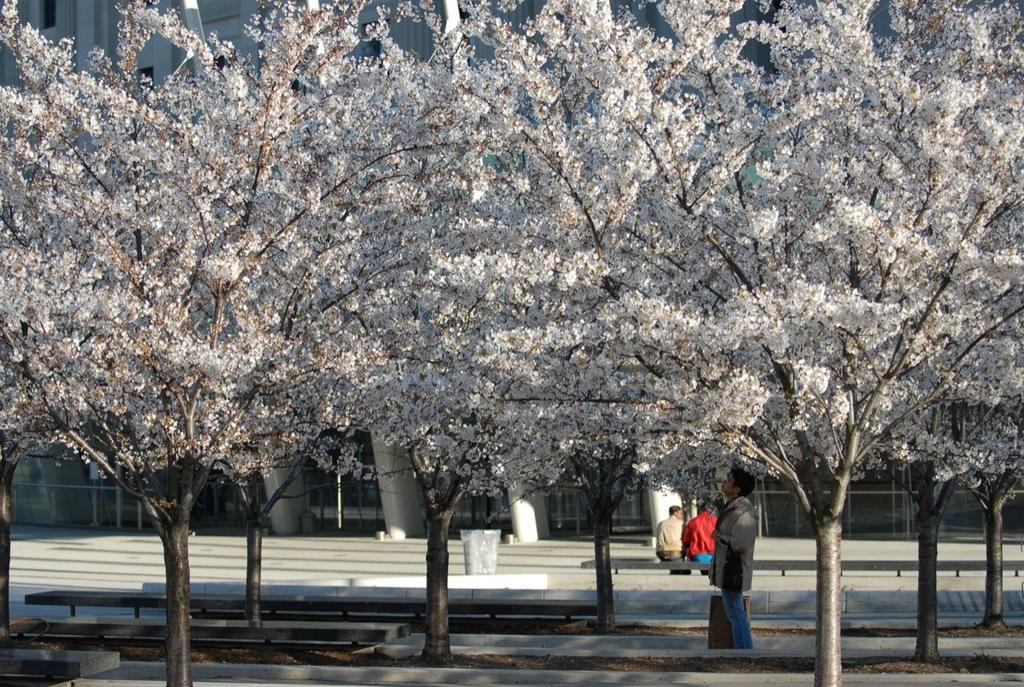What type of vegetation can be seen in the image? There are trees and flowers in the image. What are the people in the image doing? There is a group of people in the image, and some of them are seated on a bench. What can be seen in the background of the image? There are buildings and a dustbin in the background of the image. How many rabbits are hopping around the dustbin in the image? There are no rabbits present in the image. What type of arch can be seen over the bench where the people are seated? There is no arch present in the image. 